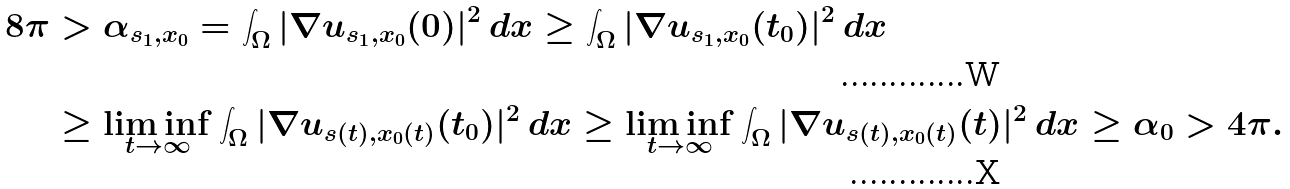Convert formula to latex. <formula><loc_0><loc_0><loc_500><loc_500>8 \pi & > \alpha _ { s _ { 1 } , x _ { 0 } } = \int _ { \Omega } | \nabla u _ { s _ { 1 } , x _ { 0 } } ( 0 ) | ^ { 2 } \, d x \geq \int _ { \Omega } | \nabla u _ { s _ { 1 } , x _ { 0 } } ( t _ { 0 } ) | ^ { 2 } \, d x \\ & \geq \liminf _ { t \rightarrow \infty } \int _ { \Omega } | \nabla u _ { s ( t ) , x _ { 0 } ( t ) } ( t _ { 0 } ) | ^ { 2 } \, d x \geq \liminf _ { t \rightarrow \infty } \int _ { \Omega } | \nabla u _ { s ( t ) , x _ { 0 } ( t ) } ( t ) | ^ { 2 } \, d x \geq \alpha _ { 0 } > 4 \pi .</formula> 